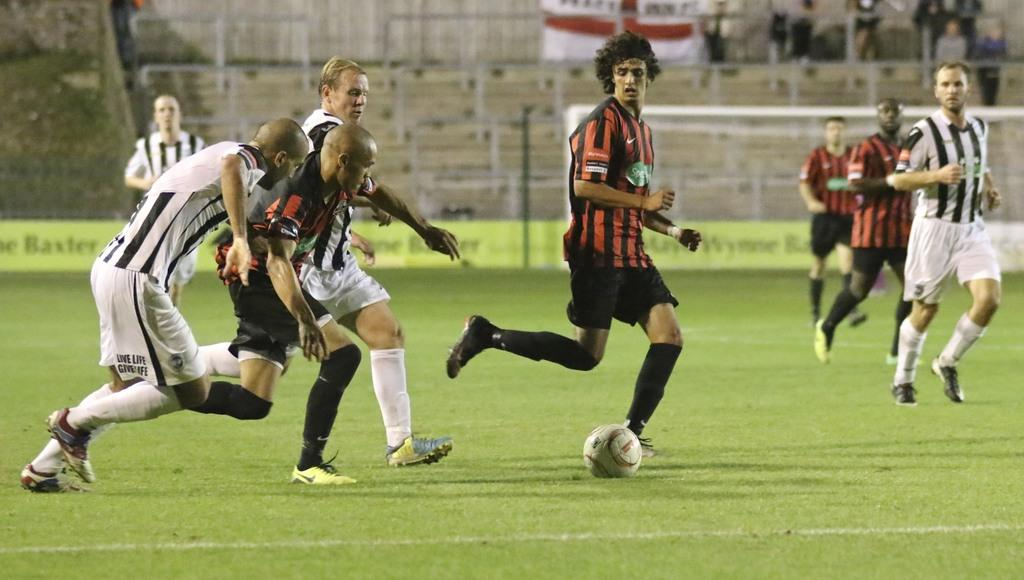What activity are the people in the image engaged in? There is a group of people playing football in the image. What can be seen in the background of the image? There are advertisement boards in the background of the image. Can you describe the people standing in the top right hand side of the image? There are persons standing in the top right hand side of the image. What type of tree can be seen in the image? There is no tree present in the image. Can you describe the monkey playing football with the group? There is no monkey present in the image; it features a group of people playing football. 